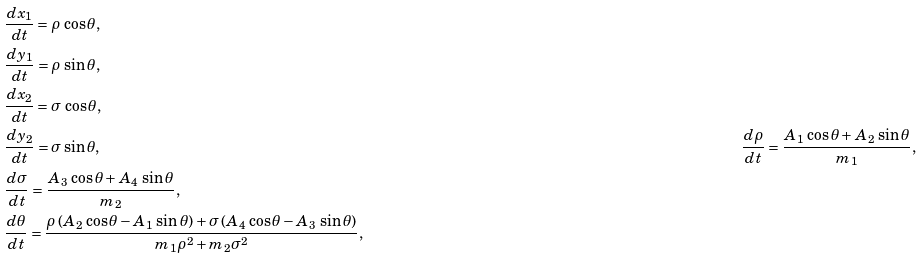Convert formula to latex. <formula><loc_0><loc_0><loc_500><loc_500>& \frac { d x _ { 1 } } { d t } = \rho \, \cos \theta , \\ & \frac { d y _ { 1 } } { d t } = \rho \, \sin \theta , \\ & \frac { d x _ { 2 } } { d t } = \sigma \, \cos \theta , \\ & \frac { d y _ { 2 } } { d t } = \sigma \sin \theta , \quad & \frac { d \rho } { d t } = \frac { A _ { 1 } \, \cos \theta + A _ { 2 } \, \sin \theta } { m _ { 1 } } , \\ & \frac { d \sigma } { d t } = \frac { A _ { 3 } \, \cos \theta + A _ { 4 } \, \sin \theta } { m _ { 2 } } , \\ & \frac { d \theta } { d t } = \frac { \rho \, ( A _ { 2 } \, \cos \theta - A _ { 1 } \, \sin \theta ) + \sigma \, ( A _ { 4 } \, \cos \theta - A _ { 3 } \, \sin \theta ) } { m _ { 1 } \rho ^ { 2 } + m _ { 2 } \sigma ^ { 2 } } ,</formula> 